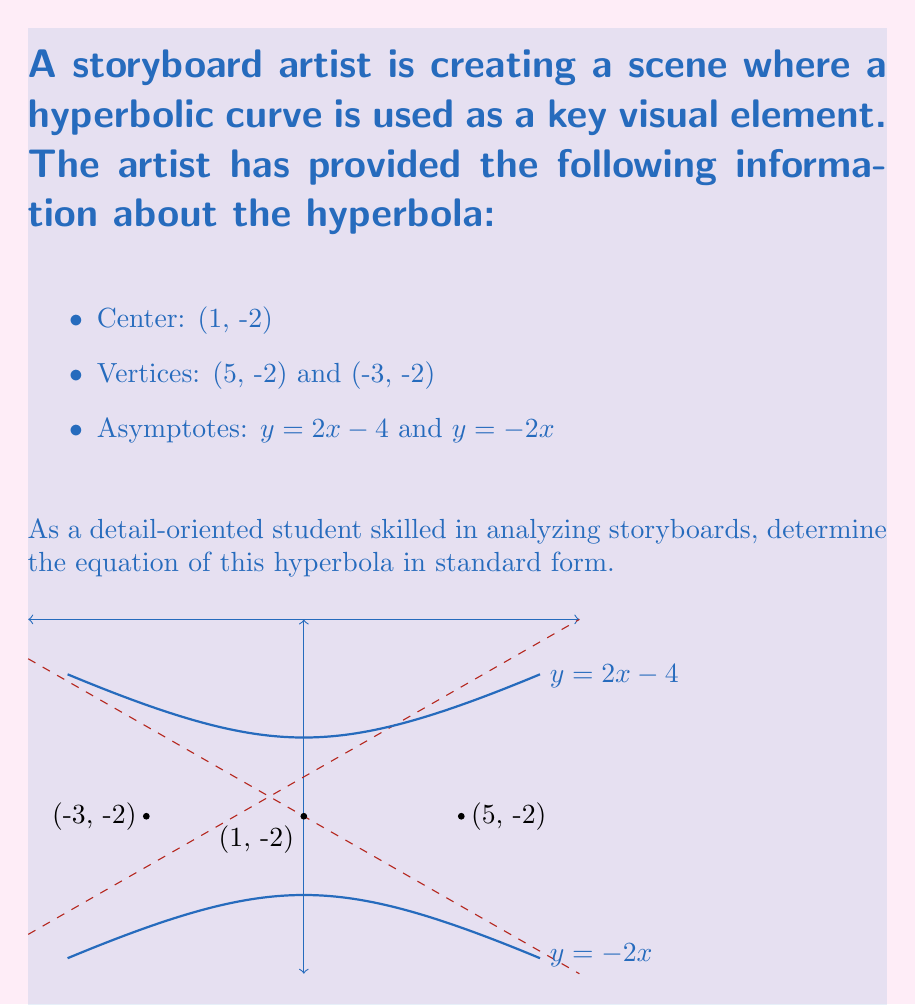Could you help me with this problem? Let's approach this step-by-step:

1) The standard form of a hyperbola with center (h, k) is:
   $$\frac{(x-h)^2}{a^2} - \frac{(y-k)^2}{b^2} = 1$$ (horizontal transverse axis)
   or
   $$\frac{(y-k)^2}{a^2} - \frac{(x-h)^2}{b^2} = 1$$ (vertical transverse axis)

2) From the given information, the center is (1, -2), so h = 1 and k = -2.

3) The vertices are on the transverse axis. Since they have the same y-coordinate as the center, we know the transverse axis is horizontal. We'll use the first equation.

4) To find a, we calculate half the distance between the vertices:
   $a = \frac{1}{2}|(5 - (-3))| = 4$

5) For a hyperbola, $c^2 = a^2 + b^2$, where c is the distance from the center to a focus.

6) We can find c from the asymptotes. The slopes of the asymptotes are $\pm \frac{b}{a}$.
   From $y = 2x - 4$, we get $\frac{b}{a} = 2$
   $b = 2a = 2(4) = 8$

7) Now we have all the components to write the equation:

   $$\frac{(x-1)^2}{16} - \frac{(y+2)^2}{64} = 1$$

8) To simplify, multiply both sides by 64:

   $$4(x-1)^2 - (y+2)^2 = 64$$
Answer: $4(x-1)^2 - (y+2)^2 = 64$ 